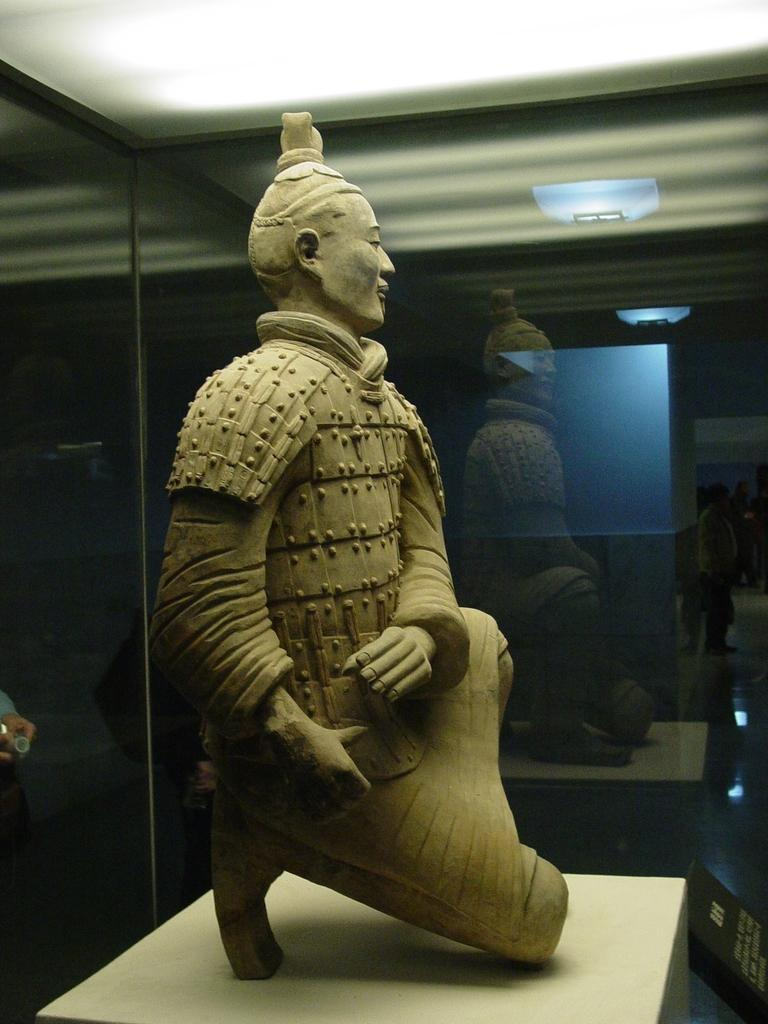What is the main subject of the image? There is a sculpture in the image. How is the sculpture displayed? The sculpture is inside a glass box. What can be seen in the background of the image? There is a reflection of people in the background. What type of lighting is present in the image? There are lights visible in the image. What type of sack is being used to store the substance in the image? There is no sack or substance present in the image; it features a sculpture inside a glass box with a background reflection of people and visible lights. Can you describe the fang of the creature in the image? There is no creature with a fang present in the image; it features a sculpture inside a glass box with a background reflection of people and visible lights. 